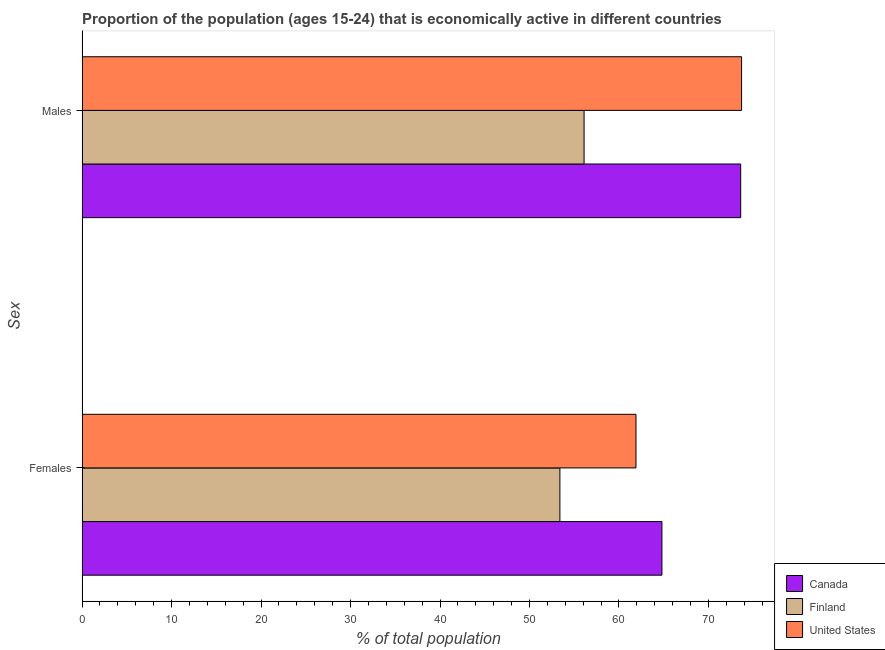How many groups of bars are there?
Your response must be concise. 2. Are the number of bars per tick equal to the number of legend labels?
Offer a very short reply. Yes. Are the number of bars on each tick of the Y-axis equal?
Provide a short and direct response. Yes. How many bars are there on the 2nd tick from the top?
Your answer should be very brief. 3. What is the label of the 2nd group of bars from the top?
Your answer should be very brief. Females. What is the percentage of economically active female population in Canada?
Give a very brief answer. 64.8. Across all countries, what is the maximum percentage of economically active female population?
Give a very brief answer. 64.8. Across all countries, what is the minimum percentage of economically active female population?
Your answer should be very brief. 53.4. In which country was the percentage of economically active male population maximum?
Keep it short and to the point. United States. What is the total percentage of economically active male population in the graph?
Your answer should be compact. 203.4. What is the difference between the percentage of economically active male population in Canada and that in Finland?
Offer a terse response. 17.5. What is the difference between the percentage of economically active male population in Canada and the percentage of economically active female population in Finland?
Provide a succinct answer. 20.2. What is the average percentage of economically active male population per country?
Offer a very short reply. 67.8. What is the difference between the percentage of economically active female population and percentage of economically active male population in United States?
Your answer should be compact. -11.8. In how many countries, is the percentage of economically active female population greater than 4 %?
Provide a succinct answer. 3. What is the ratio of the percentage of economically active female population in United States to that in Canada?
Ensure brevity in your answer.  0.96. Is the percentage of economically active female population in United States less than that in Finland?
Ensure brevity in your answer.  No. What does the 3rd bar from the bottom in Females represents?
Your answer should be compact. United States. How many bars are there?
Ensure brevity in your answer.  6. Are all the bars in the graph horizontal?
Offer a very short reply. Yes. How many countries are there in the graph?
Your answer should be compact. 3. Does the graph contain any zero values?
Your answer should be very brief. No. Does the graph contain grids?
Offer a terse response. No. Where does the legend appear in the graph?
Provide a short and direct response. Bottom right. How are the legend labels stacked?
Provide a short and direct response. Vertical. What is the title of the graph?
Ensure brevity in your answer.  Proportion of the population (ages 15-24) that is economically active in different countries. Does "Argentina" appear as one of the legend labels in the graph?
Provide a succinct answer. No. What is the label or title of the X-axis?
Your answer should be compact. % of total population. What is the label or title of the Y-axis?
Your answer should be very brief. Sex. What is the % of total population of Canada in Females?
Make the answer very short. 64.8. What is the % of total population of Finland in Females?
Your answer should be compact. 53.4. What is the % of total population of United States in Females?
Give a very brief answer. 61.9. What is the % of total population of Canada in Males?
Provide a short and direct response. 73.6. What is the % of total population of Finland in Males?
Ensure brevity in your answer.  56.1. What is the % of total population of United States in Males?
Provide a short and direct response. 73.7. Across all Sex, what is the maximum % of total population in Canada?
Ensure brevity in your answer.  73.6. Across all Sex, what is the maximum % of total population in Finland?
Provide a succinct answer. 56.1. Across all Sex, what is the maximum % of total population in United States?
Ensure brevity in your answer.  73.7. Across all Sex, what is the minimum % of total population of Canada?
Offer a very short reply. 64.8. Across all Sex, what is the minimum % of total population of Finland?
Your answer should be very brief. 53.4. Across all Sex, what is the minimum % of total population in United States?
Your answer should be compact. 61.9. What is the total % of total population of Canada in the graph?
Your answer should be very brief. 138.4. What is the total % of total population of Finland in the graph?
Give a very brief answer. 109.5. What is the total % of total population in United States in the graph?
Give a very brief answer. 135.6. What is the difference between the % of total population in United States in Females and that in Males?
Provide a succinct answer. -11.8. What is the difference between the % of total population in Finland in Females and the % of total population in United States in Males?
Offer a very short reply. -20.3. What is the average % of total population in Canada per Sex?
Ensure brevity in your answer.  69.2. What is the average % of total population in Finland per Sex?
Ensure brevity in your answer.  54.75. What is the average % of total population of United States per Sex?
Keep it short and to the point. 67.8. What is the difference between the % of total population in Finland and % of total population in United States in Males?
Provide a short and direct response. -17.6. What is the ratio of the % of total population in Canada in Females to that in Males?
Give a very brief answer. 0.88. What is the ratio of the % of total population of Finland in Females to that in Males?
Give a very brief answer. 0.95. What is the ratio of the % of total population of United States in Females to that in Males?
Keep it short and to the point. 0.84. What is the difference between the highest and the second highest % of total population in Canada?
Your answer should be very brief. 8.8. What is the difference between the highest and the second highest % of total population of Finland?
Keep it short and to the point. 2.7. What is the difference between the highest and the second highest % of total population of United States?
Your response must be concise. 11.8. What is the difference between the highest and the lowest % of total population of Canada?
Offer a terse response. 8.8. What is the difference between the highest and the lowest % of total population in Finland?
Your response must be concise. 2.7. 